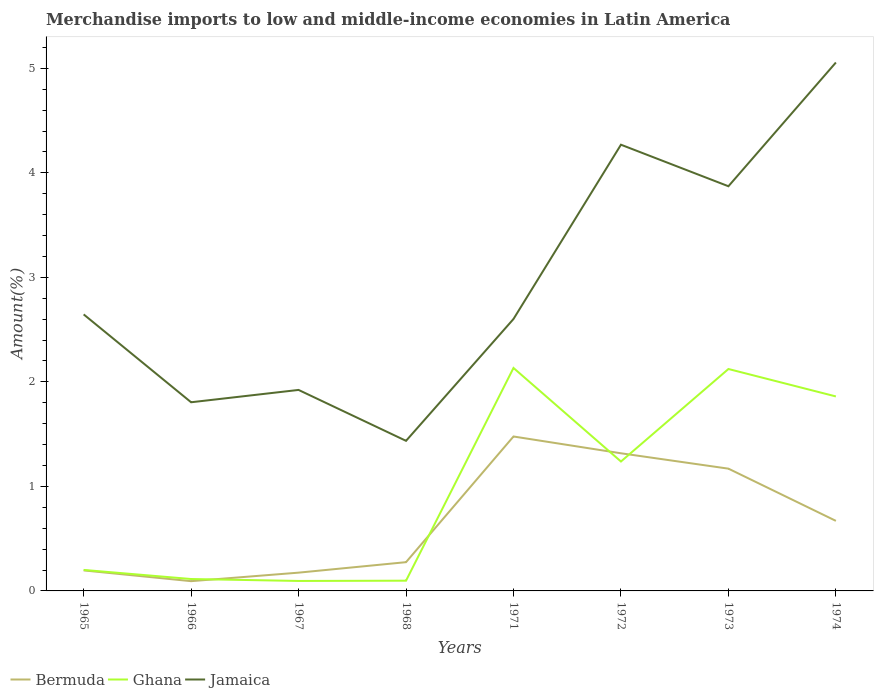Does the line corresponding to Jamaica intersect with the line corresponding to Bermuda?
Offer a terse response. No. Is the number of lines equal to the number of legend labels?
Keep it short and to the point. Yes. Across all years, what is the maximum percentage of amount earned from merchandise imports in Bermuda?
Keep it short and to the point. 0.09. In which year was the percentage of amount earned from merchandise imports in Ghana maximum?
Your answer should be very brief. 1967. What is the total percentage of amount earned from merchandise imports in Jamaica in the graph?
Your answer should be compact. 0.84. What is the difference between the highest and the second highest percentage of amount earned from merchandise imports in Bermuda?
Offer a very short reply. 1.38. What is the difference between the highest and the lowest percentage of amount earned from merchandise imports in Jamaica?
Ensure brevity in your answer.  3. How many years are there in the graph?
Ensure brevity in your answer.  8. Does the graph contain grids?
Your answer should be compact. No. How many legend labels are there?
Offer a very short reply. 3. What is the title of the graph?
Your answer should be very brief. Merchandise imports to low and middle-income economies in Latin America. What is the label or title of the Y-axis?
Provide a succinct answer. Amount(%). What is the Amount(%) of Bermuda in 1965?
Offer a terse response. 0.2. What is the Amount(%) in Ghana in 1965?
Keep it short and to the point. 0.2. What is the Amount(%) in Jamaica in 1965?
Your response must be concise. 2.65. What is the Amount(%) in Bermuda in 1966?
Provide a short and direct response. 0.09. What is the Amount(%) of Ghana in 1966?
Your response must be concise. 0.11. What is the Amount(%) of Jamaica in 1966?
Your response must be concise. 1.81. What is the Amount(%) of Bermuda in 1967?
Make the answer very short. 0.17. What is the Amount(%) of Ghana in 1967?
Give a very brief answer. 0.1. What is the Amount(%) in Jamaica in 1967?
Provide a succinct answer. 1.92. What is the Amount(%) in Bermuda in 1968?
Ensure brevity in your answer.  0.28. What is the Amount(%) in Ghana in 1968?
Your answer should be very brief. 0.1. What is the Amount(%) in Jamaica in 1968?
Offer a very short reply. 1.44. What is the Amount(%) in Bermuda in 1971?
Ensure brevity in your answer.  1.48. What is the Amount(%) of Ghana in 1971?
Your response must be concise. 2.13. What is the Amount(%) in Jamaica in 1971?
Make the answer very short. 2.6. What is the Amount(%) in Bermuda in 1972?
Make the answer very short. 1.32. What is the Amount(%) in Ghana in 1972?
Your answer should be very brief. 1.24. What is the Amount(%) in Jamaica in 1972?
Give a very brief answer. 4.27. What is the Amount(%) in Bermuda in 1973?
Your answer should be compact. 1.17. What is the Amount(%) in Ghana in 1973?
Your response must be concise. 2.12. What is the Amount(%) in Jamaica in 1973?
Your response must be concise. 3.87. What is the Amount(%) of Bermuda in 1974?
Give a very brief answer. 0.67. What is the Amount(%) in Ghana in 1974?
Keep it short and to the point. 1.86. What is the Amount(%) in Jamaica in 1974?
Provide a succinct answer. 5.06. Across all years, what is the maximum Amount(%) of Bermuda?
Make the answer very short. 1.48. Across all years, what is the maximum Amount(%) of Ghana?
Make the answer very short. 2.13. Across all years, what is the maximum Amount(%) in Jamaica?
Keep it short and to the point. 5.06. Across all years, what is the minimum Amount(%) of Bermuda?
Ensure brevity in your answer.  0.09. Across all years, what is the minimum Amount(%) of Ghana?
Offer a terse response. 0.1. Across all years, what is the minimum Amount(%) in Jamaica?
Offer a very short reply. 1.44. What is the total Amount(%) in Bermuda in the graph?
Provide a short and direct response. 5.37. What is the total Amount(%) in Ghana in the graph?
Make the answer very short. 7.86. What is the total Amount(%) of Jamaica in the graph?
Ensure brevity in your answer.  23.61. What is the difference between the Amount(%) of Bermuda in 1965 and that in 1966?
Your answer should be very brief. 0.1. What is the difference between the Amount(%) in Ghana in 1965 and that in 1966?
Make the answer very short. 0.09. What is the difference between the Amount(%) in Jamaica in 1965 and that in 1966?
Provide a short and direct response. 0.84. What is the difference between the Amount(%) in Bermuda in 1965 and that in 1967?
Keep it short and to the point. 0.02. What is the difference between the Amount(%) of Ghana in 1965 and that in 1967?
Provide a short and direct response. 0.11. What is the difference between the Amount(%) in Jamaica in 1965 and that in 1967?
Ensure brevity in your answer.  0.72. What is the difference between the Amount(%) of Bermuda in 1965 and that in 1968?
Keep it short and to the point. -0.08. What is the difference between the Amount(%) in Ghana in 1965 and that in 1968?
Ensure brevity in your answer.  0.1. What is the difference between the Amount(%) of Jamaica in 1965 and that in 1968?
Your response must be concise. 1.21. What is the difference between the Amount(%) in Bermuda in 1965 and that in 1971?
Your answer should be very brief. -1.28. What is the difference between the Amount(%) of Ghana in 1965 and that in 1971?
Provide a short and direct response. -1.93. What is the difference between the Amount(%) of Jamaica in 1965 and that in 1971?
Offer a terse response. 0.04. What is the difference between the Amount(%) of Bermuda in 1965 and that in 1972?
Give a very brief answer. -1.12. What is the difference between the Amount(%) in Ghana in 1965 and that in 1972?
Keep it short and to the point. -1.04. What is the difference between the Amount(%) in Jamaica in 1965 and that in 1972?
Your response must be concise. -1.62. What is the difference between the Amount(%) of Bermuda in 1965 and that in 1973?
Keep it short and to the point. -0.97. What is the difference between the Amount(%) of Ghana in 1965 and that in 1973?
Make the answer very short. -1.92. What is the difference between the Amount(%) of Jamaica in 1965 and that in 1973?
Offer a very short reply. -1.23. What is the difference between the Amount(%) in Bermuda in 1965 and that in 1974?
Offer a terse response. -0.47. What is the difference between the Amount(%) in Ghana in 1965 and that in 1974?
Your answer should be very brief. -1.66. What is the difference between the Amount(%) of Jamaica in 1965 and that in 1974?
Your response must be concise. -2.41. What is the difference between the Amount(%) in Bermuda in 1966 and that in 1967?
Offer a very short reply. -0.08. What is the difference between the Amount(%) of Ghana in 1966 and that in 1967?
Give a very brief answer. 0.02. What is the difference between the Amount(%) of Jamaica in 1966 and that in 1967?
Your response must be concise. -0.12. What is the difference between the Amount(%) in Bermuda in 1966 and that in 1968?
Offer a terse response. -0.18. What is the difference between the Amount(%) in Ghana in 1966 and that in 1968?
Give a very brief answer. 0.02. What is the difference between the Amount(%) in Jamaica in 1966 and that in 1968?
Keep it short and to the point. 0.37. What is the difference between the Amount(%) in Bermuda in 1966 and that in 1971?
Your response must be concise. -1.38. What is the difference between the Amount(%) of Ghana in 1966 and that in 1971?
Your answer should be compact. -2.02. What is the difference between the Amount(%) in Jamaica in 1966 and that in 1971?
Provide a short and direct response. -0.8. What is the difference between the Amount(%) of Bermuda in 1966 and that in 1972?
Make the answer very short. -1.22. What is the difference between the Amount(%) in Ghana in 1966 and that in 1972?
Your response must be concise. -1.12. What is the difference between the Amount(%) in Jamaica in 1966 and that in 1972?
Provide a succinct answer. -2.46. What is the difference between the Amount(%) in Bermuda in 1966 and that in 1973?
Keep it short and to the point. -1.08. What is the difference between the Amount(%) of Ghana in 1966 and that in 1973?
Provide a short and direct response. -2.01. What is the difference between the Amount(%) of Jamaica in 1966 and that in 1973?
Your answer should be very brief. -2.07. What is the difference between the Amount(%) of Bermuda in 1966 and that in 1974?
Your response must be concise. -0.58. What is the difference between the Amount(%) in Ghana in 1966 and that in 1974?
Ensure brevity in your answer.  -1.75. What is the difference between the Amount(%) in Jamaica in 1966 and that in 1974?
Ensure brevity in your answer.  -3.25. What is the difference between the Amount(%) in Bermuda in 1967 and that in 1968?
Make the answer very short. -0.1. What is the difference between the Amount(%) in Ghana in 1967 and that in 1968?
Keep it short and to the point. -0. What is the difference between the Amount(%) of Jamaica in 1967 and that in 1968?
Provide a succinct answer. 0.49. What is the difference between the Amount(%) of Bermuda in 1967 and that in 1971?
Offer a terse response. -1.3. What is the difference between the Amount(%) of Ghana in 1967 and that in 1971?
Your answer should be very brief. -2.04. What is the difference between the Amount(%) of Jamaica in 1967 and that in 1971?
Offer a very short reply. -0.68. What is the difference between the Amount(%) in Bermuda in 1967 and that in 1972?
Provide a succinct answer. -1.14. What is the difference between the Amount(%) in Ghana in 1967 and that in 1972?
Offer a very short reply. -1.14. What is the difference between the Amount(%) of Jamaica in 1967 and that in 1972?
Give a very brief answer. -2.35. What is the difference between the Amount(%) of Bermuda in 1967 and that in 1973?
Provide a short and direct response. -0.99. What is the difference between the Amount(%) of Ghana in 1967 and that in 1973?
Your answer should be compact. -2.03. What is the difference between the Amount(%) in Jamaica in 1967 and that in 1973?
Give a very brief answer. -1.95. What is the difference between the Amount(%) of Bermuda in 1967 and that in 1974?
Offer a very short reply. -0.5. What is the difference between the Amount(%) of Ghana in 1967 and that in 1974?
Keep it short and to the point. -1.77. What is the difference between the Amount(%) in Jamaica in 1967 and that in 1974?
Provide a short and direct response. -3.13. What is the difference between the Amount(%) in Bermuda in 1968 and that in 1971?
Your answer should be very brief. -1.2. What is the difference between the Amount(%) in Ghana in 1968 and that in 1971?
Your answer should be very brief. -2.04. What is the difference between the Amount(%) of Jamaica in 1968 and that in 1971?
Offer a terse response. -1.17. What is the difference between the Amount(%) in Bermuda in 1968 and that in 1972?
Offer a terse response. -1.04. What is the difference between the Amount(%) in Ghana in 1968 and that in 1972?
Make the answer very short. -1.14. What is the difference between the Amount(%) of Jamaica in 1968 and that in 1972?
Give a very brief answer. -2.83. What is the difference between the Amount(%) in Bermuda in 1968 and that in 1973?
Your response must be concise. -0.89. What is the difference between the Amount(%) in Ghana in 1968 and that in 1973?
Offer a terse response. -2.03. What is the difference between the Amount(%) of Jamaica in 1968 and that in 1973?
Ensure brevity in your answer.  -2.44. What is the difference between the Amount(%) in Bermuda in 1968 and that in 1974?
Your response must be concise. -0.4. What is the difference between the Amount(%) in Ghana in 1968 and that in 1974?
Offer a very short reply. -1.76. What is the difference between the Amount(%) in Jamaica in 1968 and that in 1974?
Keep it short and to the point. -3.62. What is the difference between the Amount(%) in Bermuda in 1971 and that in 1972?
Provide a short and direct response. 0.16. What is the difference between the Amount(%) in Ghana in 1971 and that in 1972?
Give a very brief answer. 0.9. What is the difference between the Amount(%) of Jamaica in 1971 and that in 1972?
Make the answer very short. -1.67. What is the difference between the Amount(%) in Bermuda in 1971 and that in 1973?
Give a very brief answer. 0.31. What is the difference between the Amount(%) in Jamaica in 1971 and that in 1973?
Give a very brief answer. -1.27. What is the difference between the Amount(%) in Bermuda in 1971 and that in 1974?
Offer a very short reply. 0.81. What is the difference between the Amount(%) of Ghana in 1971 and that in 1974?
Offer a very short reply. 0.27. What is the difference between the Amount(%) of Jamaica in 1971 and that in 1974?
Make the answer very short. -2.45. What is the difference between the Amount(%) in Bermuda in 1972 and that in 1973?
Ensure brevity in your answer.  0.15. What is the difference between the Amount(%) in Ghana in 1972 and that in 1973?
Offer a terse response. -0.89. What is the difference between the Amount(%) in Jamaica in 1972 and that in 1973?
Ensure brevity in your answer.  0.4. What is the difference between the Amount(%) in Bermuda in 1972 and that in 1974?
Your answer should be compact. 0.65. What is the difference between the Amount(%) in Ghana in 1972 and that in 1974?
Ensure brevity in your answer.  -0.62. What is the difference between the Amount(%) in Jamaica in 1972 and that in 1974?
Keep it short and to the point. -0.79. What is the difference between the Amount(%) of Bermuda in 1973 and that in 1974?
Provide a succinct answer. 0.5. What is the difference between the Amount(%) in Ghana in 1973 and that in 1974?
Your answer should be compact. 0.26. What is the difference between the Amount(%) of Jamaica in 1973 and that in 1974?
Provide a succinct answer. -1.18. What is the difference between the Amount(%) of Bermuda in 1965 and the Amount(%) of Ghana in 1966?
Provide a succinct answer. 0.08. What is the difference between the Amount(%) in Bermuda in 1965 and the Amount(%) in Jamaica in 1966?
Keep it short and to the point. -1.61. What is the difference between the Amount(%) in Ghana in 1965 and the Amount(%) in Jamaica in 1966?
Make the answer very short. -1.6. What is the difference between the Amount(%) of Bermuda in 1965 and the Amount(%) of Ghana in 1967?
Provide a short and direct response. 0.1. What is the difference between the Amount(%) in Bermuda in 1965 and the Amount(%) in Jamaica in 1967?
Your answer should be compact. -1.73. What is the difference between the Amount(%) in Ghana in 1965 and the Amount(%) in Jamaica in 1967?
Your response must be concise. -1.72. What is the difference between the Amount(%) of Bermuda in 1965 and the Amount(%) of Ghana in 1968?
Offer a terse response. 0.1. What is the difference between the Amount(%) of Bermuda in 1965 and the Amount(%) of Jamaica in 1968?
Keep it short and to the point. -1.24. What is the difference between the Amount(%) in Ghana in 1965 and the Amount(%) in Jamaica in 1968?
Offer a very short reply. -1.24. What is the difference between the Amount(%) of Bermuda in 1965 and the Amount(%) of Ghana in 1971?
Your answer should be very brief. -1.94. What is the difference between the Amount(%) in Bermuda in 1965 and the Amount(%) in Jamaica in 1971?
Offer a very short reply. -2.41. What is the difference between the Amount(%) in Ghana in 1965 and the Amount(%) in Jamaica in 1971?
Make the answer very short. -2.4. What is the difference between the Amount(%) in Bermuda in 1965 and the Amount(%) in Ghana in 1972?
Give a very brief answer. -1.04. What is the difference between the Amount(%) in Bermuda in 1965 and the Amount(%) in Jamaica in 1972?
Offer a very short reply. -4.07. What is the difference between the Amount(%) of Ghana in 1965 and the Amount(%) of Jamaica in 1972?
Provide a short and direct response. -4.07. What is the difference between the Amount(%) of Bermuda in 1965 and the Amount(%) of Ghana in 1973?
Provide a short and direct response. -1.93. What is the difference between the Amount(%) of Bermuda in 1965 and the Amount(%) of Jamaica in 1973?
Give a very brief answer. -3.68. What is the difference between the Amount(%) in Ghana in 1965 and the Amount(%) in Jamaica in 1973?
Provide a succinct answer. -3.67. What is the difference between the Amount(%) of Bermuda in 1965 and the Amount(%) of Ghana in 1974?
Keep it short and to the point. -1.66. What is the difference between the Amount(%) of Bermuda in 1965 and the Amount(%) of Jamaica in 1974?
Your response must be concise. -4.86. What is the difference between the Amount(%) of Ghana in 1965 and the Amount(%) of Jamaica in 1974?
Make the answer very short. -4.86. What is the difference between the Amount(%) in Bermuda in 1966 and the Amount(%) in Ghana in 1967?
Make the answer very short. -0. What is the difference between the Amount(%) in Bermuda in 1966 and the Amount(%) in Jamaica in 1967?
Your answer should be very brief. -1.83. What is the difference between the Amount(%) of Ghana in 1966 and the Amount(%) of Jamaica in 1967?
Provide a short and direct response. -1.81. What is the difference between the Amount(%) in Bermuda in 1966 and the Amount(%) in Ghana in 1968?
Make the answer very short. -0. What is the difference between the Amount(%) in Bermuda in 1966 and the Amount(%) in Jamaica in 1968?
Ensure brevity in your answer.  -1.34. What is the difference between the Amount(%) in Ghana in 1966 and the Amount(%) in Jamaica in 1968?
Your response must be concise. -1.32. What is the difference between the Amount(%) in Bermuda in 1966 and the Amount(%) in Ghana in 1971?
Offer a very short reply. -2.04. What is the difference between the Amount(%) in Bermuda in 1966 and the Amount(%) in Jamaica in 1971?
Ensure brevity in your answer.  -2.51. What is the difference between the Amount(%) in Ghana in 1966 and the Amount(%) in Jamaica in 1971?
Your answer should be compact. -2.49. What is the difference between the Amount(%) in Bermuda in 1966 and the Amount(%) in Ghana in 1972?
Your answer should be compact. -1.14. What is the difference between the Amount(%) of Bermuda in 1966 and the Amount(%) of Jamaica in 1972?
Ensure brevity in your answer.  -4.18. What is the difference between the Amount(%) of Ghana in 1966 and the Amount(%) of Jamaica in 1972?
Provide a succinct answer. -4.16. What is the difference between the Amount(%) in Bermuda in 1966 and the Amount(%) in Ghana in 1973?
Provide a succinct answer. -2.03. What is the difference between the Amount(%) in Bermuda in 1966 and the Amount(%) in Jamaica in 1973?
Keep it short and to the point. -3.78. What is the difference between the Amount(%) in Ghana in 1966 and the Amount(%) in Jamaica in 1973?
Offer a very short reply. -3.76. What is the difference between the Amount(%) in Bermuda in 1966 and the Amount(%) in Ghana in 1974?
Provide a short and direct response. -1.77. What is the difference between the Amount(%) in Bermuda in 1966 and the Amount(%) in Jamaica in 1974?
Provide a succinct answer. -4.96. What is the difference between the Amount(%) of Ghana in 1966 and the Amount(%) of Jamaica in 1974?
Provide a short and direct response. -4.94. What is the difference between the Amount(%) of Bermuda in 1967 and the Amount(%) of Ghana in 1968?
Provide a succinct answer. 0.08. What is the difference between the Amount(%) in Bermuda in 1967 and the Amount(%) in Jamaica in 1968?
Provide a succinct answer. -1.26. What is the difference between the Amount(%) in Ghana in 1967 and the Amount(%) in Jamaica in 1968?
Your response must be concise. -1.34. What is the difference between the Amount(%) of Bermuda in 1967 and the Amount(%) of Ghana in 1971?
Your response must be concise. -1.96. What is the difference between the Amount(%) in Bermuda in 1967 and the Amount(%) in Jamaica in 1971?
Your answer should be compact. -2.43. What is the difference between the Amount(%) of Ghana in 1967 and the Amount(%) of Jamaica in 1971?
Provide a succinct answer. -2.51. What is the difference between the Amount(%) of Bermuda in 1967 and the Amount(%) of Ghana in 1972?
Your answer should be compact. -1.06. What is the difference between the Amount(%) in Bermuda in 1967 and the Amount(%) in Jamaica in 1972?
Provide a short and direct response. -4.09. What is the difference between the Amount(%) in Ghana in 1967 and the Amount(%) in Jamaica in 1972?
Make the answer very short. -4.17. What is the difference between the Amount(%) of Bermuda in 1967 and the Amount(%) of Ghana in 1973?
Keep it short and to the point. -1.95. What is the difference between the Amount(%) in Bermuda in 1967 and the Amount(%) in Jamaica in 1973?
Keep it short and to the point. -3.7. What is the difference between the Amount(%) of Ghana in 1967 and the Amount(%) of Jamaica in 1973?
Offer a very short reply. -3.78. What is the difference between the Amount(%) in Bermuda in 1967 and the Amount(%) in Ghana in 1974?
Offer a very short reply. -1.69. What is the difference between the Amount(%) of Bermuda in 1967 and the Amount(%) of Jamaica in 1974?
Offer a very short reply. -4.88. What is the difference between the Amount(%) of Ghana in 1967 and the Amount(%) of Jamaica in 1974?
Your answer should be very brief. -4.96. What is the difference between the Amount(%) of Bermuda in 1968 and the Amount(%) of Ghana in 1971?
Keep it short and to the point. -1.86. What is the difference between the Amount(%) of Bermuda in 1968 and the Amount(%) of Jamaica in 1971?
Offer a terse response. -2.33. What is the difference between the Amount(%) in Ghana in 1968 and the Amount(%) in Jamaica in 1971?
Make the answer very short. -2.5. What is the difference between the Amount(%) of Bermuda in 1968 and the Amount(%) of Ghana in 1972?
Give a very brief answer. -0.96. What is the difference between the Amount(%) in Bermuda in 1968 and the Amount(%) in Jamaica in 1972?
Give a very brief answer. -3.99. What is the difference between the Amount(%) in Ghana in 1968 and the Amount(%) in Jamaica in 1972?
Ensure brevity in your answer.  -4.17. What is the difference between the Amount(%) of Bermuda in 1968 and the Amount(%) of Ghana in 1973?
Make the answer very short. -1.85. What is the difference between the Amount(%) of Bermuda in 1968 and the Amount(%) of Jamaica in 1973?
Your answer should be very brief. -3.6. What is the difference between the Amount(%) in Ghana in 1968 and the Amount(%) in Jamaica in 1973?
Make the answer very short. -3.77. What is the difference between the Amount(%) in Bermuda in 1968 and the Amount(%) in Ghana in 1974?
Ensure brevity in your answer.  -1.59. What is the difference between the Amount(%) of Bermuda in 1968 and the Amount(%) of Jamaica in 1974?
Provide a short and direct response. -4.78. What is the difference between the Amount(%) of Ghana in 1968 and the Amount(%) of Jamaica in 1974?
Your answer should be very brief. -4.96. What is the difference between the Amount(%) of Bermuda in 1971 and the Amount(%) of Ghana in 1972?
Provide a succinct answer. 0.24. What is the difference between the Amount(%) of Bermuda in 1971 and the Amount(%) of Jamaica in 1972?
Your answer should be compact. -2.79. What is the difference between the Amount(%) in Ghana in 1971 and the Amount(%) in Jamaica in 1972?
Ensure brevity in your answer.  -2.14. What is the difference between the Amount(%) in Bermuda in 1971 and the Amount(%) in Ghana in 1973?
Your answer should be compact. -0.65. What is the difference between the Amount(%) in Bermuda in 1971 and the Amount(%) in Jamaica in 1973?
Provide a succinct answer. -2.39. What is the difference between the Amount(%) of Ghana in 1971 and the Amount(%) of Jamaica in 1973?
Offer a terse response. -1.74. What is the difference between the Amount(%) of Bermuda in 1971 and the Amount(%) of Ghana in 1974?
Offer a very short reply. -0.38. What is the difference between the Amount(%) in Bermuda in 1971 and the Amount(%) in Jamaica in 1974?
Provide a succinct answer. -3.58. What is the difference between the Amount(%) of Ghana in 1971 and the Amount(%) of Jamaica in 1974?
Give a very brief answer. -2.92. What is the difference between the Amount(%) of Bermuda in 1972 and the Amount(%) of Ghana in 1973?
Ensure brevity in your answer.  -0.81. What is the difference between the Amount(%) in Bermuda in 1972 and the Amount(%) in Jamaica in 1973?
Provide a succinct answer. -2.56. What is the difference between the Amount(%) of Ghana in 1972 and the Amount(%) of Jamaica in 1973?
Offer a terse response. -2.63. What is the difference between the Amount(%) in Bermuda in 1972 and the Amount(%) in Ghana in 1974?
Keep it short and to the point. -0.54. What is the difference between the Amount(%) in Bermuda in 1972 and the Amount(%) in Jamaica in 1974?
Your answer should be very brief. -3.74. What is the difference between the Amount(%) of Ghana in 1972 and the Amount(%) of Jamaica in 1974?
Give a very brief answer. -3.82. What is the difference between the Amount(%) of Bermuda in 1973 and the Amount(%) of Ghana in 1974?
Offer a very short reply. -0.69. What is the difference between the Amount(%) of Bermuda in 1973 and the Amount(%) of Jamaica in 1974?
Your answer should be very brief. -3.89. What is the difference between the Amount(%) in Ghana in 1973 and the Amount(%) in Jamaica in 1974?
Your answer should be very brief. -2.93. What is the average Amount(%) of Bermuda per year?
Ensure brevity in your answer.  0.67. What is the average Amount(%) of Jamaica per year?
Your answer should be very brief. 2.95. In the year 1965, what is the difference between the Amount(%) of Bermuda and Amount(%) of Ghana?
Provide a succinct answer. -0. In the year 1965, what is the difference between the Amount(%) in Bermuda and Amount(%) in Jamaica?
Keep it short and to the point. -2.45. In the year 1965, what is the difference between the Amount(%) of Ghana and Amount(%) of Jamaica?
Provide a succinct answer. -2.44. In the year 1966, what is the difference between the Amount(%) of Bermuda and Amount(%) of Ghana?
Ensure brevity in your answer.  -0.02. In the year 1966, what is the difference between the Amount(%) in Bermuda and Amount(%) in Jamaica?
Ensure brevity in your answer.  -1.71. In the year 1966, what is the difference between the Amount(%) in Ghana and Amount(%) in Jamaica?
Ensure brevity in your answer.  -1.69. In the year 1967, what is the difference between the Amount(%) in Bermuda and Amount(%) in Ghana?
Provide a succinct answer. 0.08. In the year 1967, what is the difference between the Amount(%) in Bermuda and Amount(%) in Jamaica?
Offer a very short reply. -1.75. In the year 1967, what is the difference between the Amount(%) of Ghana and Amount(%) of Jamaica?
Provide a short and direct response. -1.83. In the year 1968, what is the difference between the Amount(%) in Bermuda and Amount(%) in Ghana?
Offer a very short reply. 0.18. In the year 1968, what is the difference between the Amount(%) in Bermuda and Amount(%) in Jamaica?
Provide a succinct answer. -1.16. In the year 1968, what is the difference between the Amount(%) in Ghana and Amount(%) in Jamaica?
Your response must be concise. -1.34. In the year 1971, what is the difference between the Amount(%) of Bermuda and Amount(%) of Ghana?
Offer a very short reply. -0.66. In the year 1971, what is the difference between the Amount(%) of Bermuda and Amount(%) of Jamaica?
Ensure brevity in your answer.  -1.12. In the year 1971, what is the difference between the Amount(%) of Ghana and Amount(%) of Jamaica?
Give a very brief answer. -0.47. In the year 1972, what is the difference between the Amount(%) of Bermuda and Amount(%) of Ghana?
Offer a very short reply. 0.08. In the year 1972, what is the difference between the Amount(%) of Bermuda and Amount(%) of Jamaica?
Keep it short and to the point. -2.95. In the year 1972, what is the difference between the Amount(%) in Ghana and Amount(%) in Jamaica?
Keep it short and to the point. -3.03. In the year 1973, what is the difference between the Amount(%) in Bermuda and Amount(%) in Ghana?
Ensure brevity in your answer.  -0.95. In the year 1973, what is the difference between the Amount(%) in Bermuda and Amount(%) in Jamaica?
Give a very brief answer. -2.7. In the year 1973, what is the difference between the Amount(%) in Ghana and Amount(%) in Jamaica?
Ensure brevity in your answer.  -1.75. In the year 1974, what is the difference between the Amount(%) in Bermuda and Amount(%) in Ghana?
Provide a short and direct response. -1.19. In the year 1974, what is the difference between the Amount(%) of Bermuda and Amount(%) of Jamaica?
Provide a succinct answer. -4.39. In the year 1974, what is the difference between the Amount(%) of Ghana and Amount(%) of Jamaica?
Give a very brief answer. -3.19. What is the ratio of the Amount(%) of Bermuda in 1965 to that in 1966?
Offer a terse response. 2.1. What is the ratio of the Amount(%) of Ghana in 1965 to that in 1966?
Make the answer very short. 1.76. What is the ratio of the Amount(%) of Jamaica in 1965 to that in 1966?
Offer a very short reply. 1.47. What is the ratio of the Amount(%) in Bermuda in 1965 to that in 1967?
Give a very brief answer. 1.12. What is the ratio of the Amount(%) of Ghana in 1965 to that in 1967?
Provide a short and direct response. 2.11. What is the ratio of the Amount(%) in Jamaica in 1965 to that in 1967?
Give a very brief answer. 1.38. What is the ratio of the Amount(%) of Bermuda in 1965 to that in 1968?
Your answer should be very brief. 0.71. What is the ratio of the Amount(%) of Ghana in 1965 to that in 1968?
Give a very brief answer. 2.05. What is the ratio of the Amount(%) of Jamaica in 1965 to that in 1968?
Keep it short and to the point. 1.84. What is the ratio of the Amount(%) of Bermuda in 1965 to that in 1971?
Give a very brief answer. 0.13. What is the ratio of the Amount(%) in Ghana in 1965 to that in 1971?
Ensure brevity in your answer.  0.09. What is the ratio of the Amount(%) in Jamaica in 1965 to that in 1971?
Give a very brief answer. 1.02. What is the ratio of the Amount(%) of Bermuda in 1965 to that in 1972?
Provide a short and direct response. 0.15. What is the ratio of the Amount(%) of Ghana in 1965 to that in 1972?
Ensure brevity in your answer.  0.16. What is the ratio of the Amount(%) in Jamaica in 1965 to that in 1972?
Offer a terse response. 0.62. What is the ratio of the Amount(%) of Bermuda in 1965 to that in 1973?
Offer a terse response. 0.17. What is the ratio of the Amount(%) in Ghana in 1965 to that in 1973?
Your answer should be compact. 0.09. What is the ratio of the Amount(%) in Jamaica in 1965 to that in 1973?
Your response must be concise. 0.68. What is the ratio of the Amount(%) in Bermuda in 1965 to that in 1974?
Your response must be concise. 0.29. What is the ratio of the Amount(%) of Ghana in 1965 to that in 1974?
Offer a terse response. 0.11. What is the ratio of the Amount(%) in Jamaica in 1965 to that in 1974?
Provide a short and direct response. 0.52. What is the ratio of the Amount(%) of Bermuda in 1966 to that in 1967?
Ensure brevity in your answer.  0.53. What is the ratio of the Amount(%) in Ghana in 1966 to that in 1967?
Give a very brief answer. 1.19. What is the ratio of the Amount(%) in Jamaica in 1966 to that in 1967?
Offer a very short reply. 0.94. What is the ratio of the Amount(%) of Bermuda in 1966 to that in 1968?
Provide a short and direct response. 0.34. What is the ratio of the Amount(%) of Ghana in 1966 to that in 1968?
Offer a terse response. 1.16. What is the ratio of the Amount(%) in Jamaica in 1966 to that in 1968?
Provide a short and direct response. 1.26. What is the ratio of the Amount(%) of Bermuda in 1966 to that in 1971?
Ensure brevity in your answer.  0.06. What is the ratio of the Amount(%) in Ghana in 1966 to that in 1971?
Make the answer very short. 0.05. What is the ratio of the Amount(%) in Jamaica in 1966 to that in 1971?
Your answer should be very brief. 0.69. What is the ratio of the Amount(%) of Bermuda in 1966 to that in 1972?
Offer a terse response. 0.07. What is the ratio of the Amount(%) of Ghana in 1966 to that in 1972?
Give a very brief answer. 0.09. What is the ratio of the Amount(%) in Jamaica in 1966 to that in 1972?
Your answer should be compact. 0.42. What is the ratio of the Amount(%) of Bermuda in 1966 to that in 1973?
Provide a short and direct response. 0.08. What is the ratio of the Amount(%) of Ghana in 1966 to that in 1973?
Offer a terse response. 0.05. What is the ratio of the Amount(%) in Jamaica in 1966 to that in 1973?
Make the answer very short. 0.47. What is the ratio of the Amount(%) of Bermuda in 1966 to that in 1974?
Keep it short and to the point. 0.14. What is the ratio of the Amount(%) of Ghana in 1966 to that in 1974?
Your answer should be very brief. 0.06. What is the ratio of the Amount(%) in Jamaica in 1966 to that in 1974?
Offer a terse response. 0.36. What is the ratio of the Amount(%) of Bermuda in 1967 to that in 1968?
Your response must be concise. 0.64. What is the ratio of the Amount(%) of Ghana in 1967 to that in 1968?
Provide a short and direct response. 0.97. What is the ratio of the Amount(%) of Jamaica in 1967 to that in 1968?
Your answer should be compact. 1.34. What is the ratio of the Amount(%) of Bermuda in 1967 to that in 1971?
Provide a short and direct response. 0.12. What is the ratio of the Amount(%) of Ghana in 1967 to that in 1971?
Make the answer very short. 0.04. What is the ratio of the Amount(%) of Jamaica in 1967 to that in 1971?
Ensure brevity in your answer.  0.74. What is the ratio of the Amount(%) in Bermuda in 1967 to that in 1972?
Provide a short and direct response. 0.13. What is the ratio of the Amount(%) of Ghana in 1967 to that in 1972?
Ensure brevity in your answer.  0.08. What is the ratio of the Amount(%) of Jamaica in 1967 to that in 1972?
Ensure brevity in your answer.  0.45. What is the ratio of the Amount(%) in Bermuda in 1967 to that in 1973?
Provide a short and direct response. 0.15. What is the ratio of the Amount(%) of Ghana in 1967 to that in 1973?
Make the answer very short. 0.04. What is the ratio of the Amount(%) of Jamaica in 1967 to that in 1973?
Make the answer very short. 0.5. What is the ratio of the Amount(%) in Bermuda in 1967 to that in 1974?
Provide a succinct answer. 0.26. What is the ratio of the Amount(%) in Ghana in 1967 to that in 1974?
Your response must be concise. 0.05. What is the ratio of the Amount(%) of Jamaica in 1967 to that in 1974?
Offer a terse response. 0.38. What is the ratio of the Amount(%) in Bermuda in 1968 to that in 1971?
Provide a succinct answer. 0.19. What is the ratio of the Amount(%) of Ghana in 1968 to that in 1971?
Offer a terse response. 0.05. What is the ratio of the Amount(%) of Jamaica in 1968 to that in 1971?
Provide a succinct answer. 0.55. What is the ratio of the Amount(%) of Bermuda in 1968 to that in 1972?
Your answer should be very brief. 0.21. What is the ratio of the Amount(%) of Ghana in 1968 to that in 1972?
Offer a very short reply. 0.08. What is the ratio of the Amount(%) in Jamaica in 1968 to that in 1972?
Offer a very short reply. 0.34. What is the ratio of the Amount(%) in Bermuda in 1968 to that in 1973?
Your answer should be very brief. 0.24. What is the ratio of the Amount(%) of Ghana in 1968 to that in 1973?
Ensure brevity in your answer.  0.05. What is the ratio of the Amount(%) in Jamaica in 1968 to that in 1973?
Your answer should be very brief. 0.37. What is the ratio of the Amount(%) of Bermuda in 1968 to that in 1974?
Your answer should be compact. 0.41. What is the ratio of the Amount(%) of Ghana in 1968 to that in 1974?
Give a very brief answer. 0.05. What is the ratio of the Amount(%) of Jamaica in 1968 to that in 1974?
Your answer should be compact. 0.28. What is the ratio of the Amount(%) of Bermuda in 1971 to that in 1972?
Your answer should be very brief. 1.12. What is the ratio of the Amount(%) of Ghana in 1971 to that in 1972?
Make the answer very short. 1.72. What is the ratio of the Amount(%) in Jamaica in 1971 to that in 1972?
Offer a very short reply. 0.61. What is the ratio of the Amount(%) of Bermuda in 1971 to that in 1973?
Provide a short and direct response. 1.26. What is the ratio of the Amount(%) of Ghana in 1971 to that in 1973?
Offer a terse response. 1. What is the ratio of the Amount(%) in Jamaica in 1971 to that in 1973?
Make the answer very short. 0.67. What is the ratio of the Amount(%) in Bermuda in 1971 to that in 1974?
Ensure brevity in your answer.  2.2. What is the ratio of the Amount(%) in Ghana in 1971 to that in 1974?
Make the answer very short. 1.15. What is the ratio of the Amount(%) in Jamaica in 1971 to that in 1974?
Offer a terse response. 0.51. What is the ratio of the Amount(%) of Bermuda in 1972 to that in 1973?
Offer a terse response. 1.13. What is the ratio of the Amount(%) of Ghana in 1972 to that in 1973?
Your response must be concise. 0.58. What is the ratio of the Amount(%) of Jamaica in 1972 to that in 1973?
Provide a succinct answer. 1.1. What is the ratio of the Amount(%) in Bermuda in 1972 to that in 1974?
Your answer should be compact. 1.96. What is the ratio of the Amount(%) in Ghana in 1972 to that in 1974?
Your answer should be compact. 0.67. What is the ratio of the Amount(%) in Jamaica in 1972 to that in 1974?
Your response must be concise. 0.84. What is the ratio of the Amount(%) of Bermuda in 1973 to that in 1974?
Provide a short and direct response. 1.75. What is the ratio of the Amount(%) in Ghana in 1973 to that in 1974?
Ensure brevity in your answer.  1.14. What is the ratio of the Amount(%) in Jamaica in 1973 to that in 1974?
Offer a terse response. 0.77. What is the difference between the highest and the second highest Amount(%) of Bermuda?
Ensure brevity in your answer.  0.16. What is the difference between the highest and the second highest Amount(%) of Ghana?
Provide a short and direct response. 0.01. What is the difference between the highest and the second highest Amount(%) of Jamaica?
Provide a succinct answer. 0.79. What is the difference between the highest and the lowest Amount(%) of Bermuda?
Your answer should be compact. 1.38. What is the difference between the highest and the lowest Amount(%) of Ghana?
Offer a terse response. 2.04. What is the difference between the highest and the lowest Amount(%) of Jamaica?
Provide a succinct answer. 3.62. 